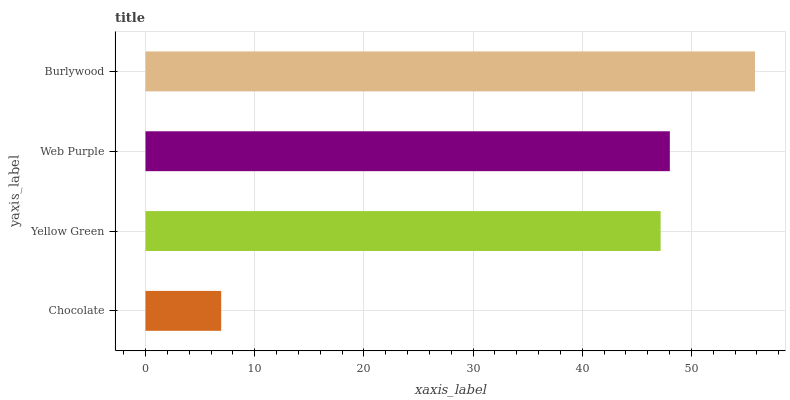Is Chocolate the minimum?
Answer yes or no. Yes. Is Burlywood the maximum?
Answer yes or no. Yes. Is Yellow Green the minimum?
Answer yes or no. No. Is Yellow Green the maximum?
Answer yes or no. No. Is Yellow Green greater than Chocolate?
Answer yes or no. Yes. Is Chocolate less than Yellow Green?
Answer yes or no. Yes. Is Chocolate greater than Yellow Green?
Answer yes or no. No. Is Yellow Green less than Chocolate?
Answer yes or no. No. Is Web Purple the high median?
Answer yes or no. Yes. Is Yellow Green the low median?
Answer yes or no. Yes. Is Chocolate the high median?
Answer yes or no. No. Is Burlywood the low median?
Answer yes or no. No. 